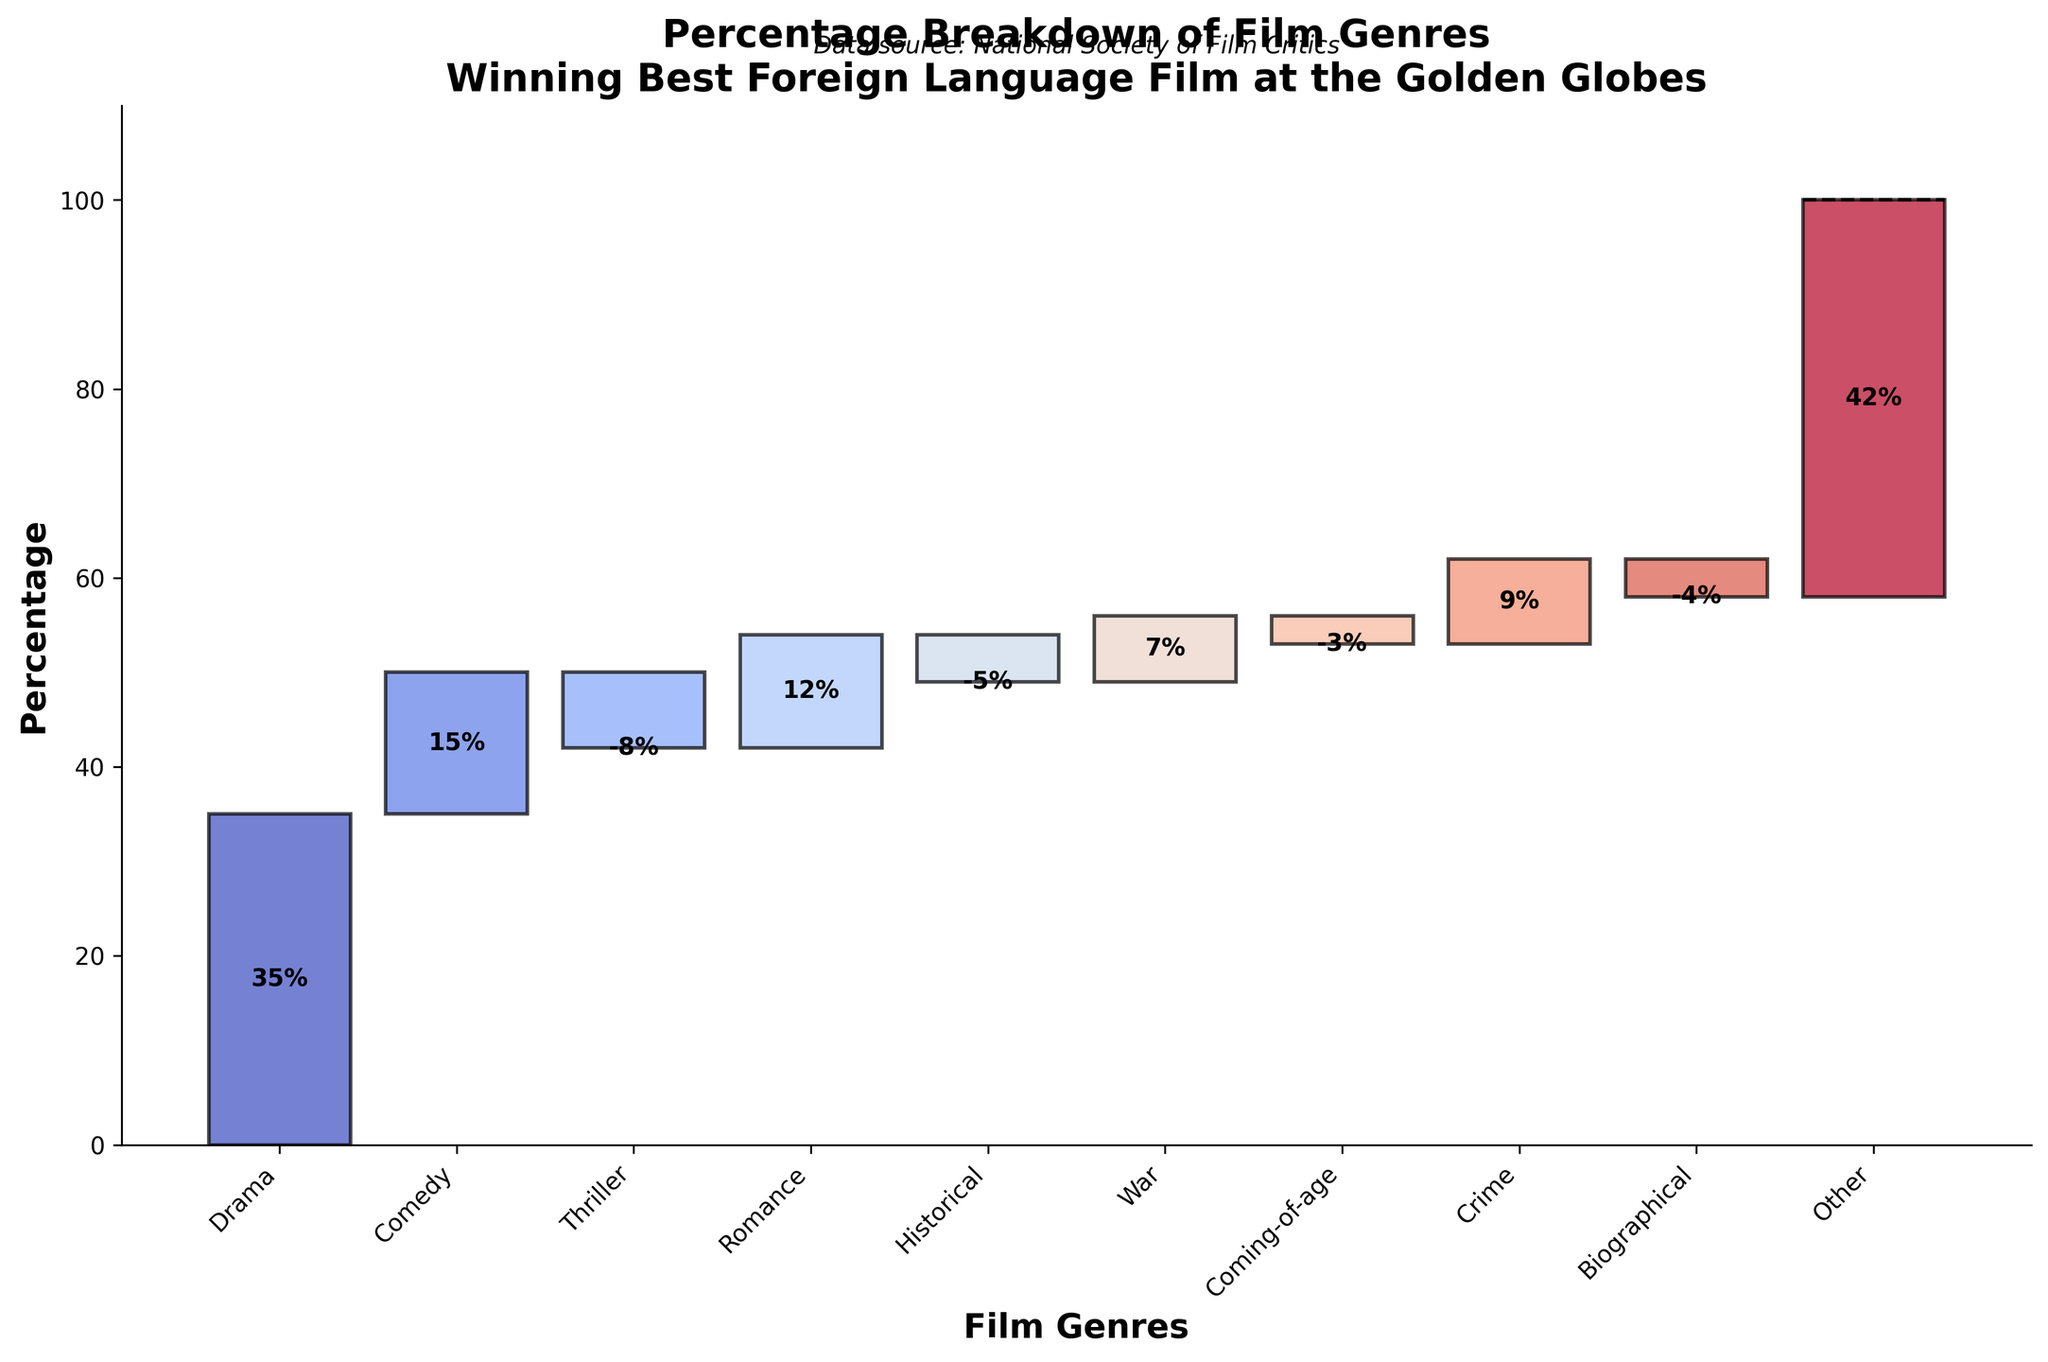What is the title of the figure? The title is usually at the top of the figure and is clearly stated.
Answer: Percentage Breakdown of Film Genres Winning Best Foreign Language Film at the Golden Globes Which genre has the highest percentage? From the figure, 'Drama' has the highest individual percentage at 35%.
Answer: Drama What is the total percentage of 'Comedy' and 'Romance' genres combined? Sum the percentages of 'Comedy' (15%) and 'Romance' (12%).
Answer: 27% Which genres have a negative percentage? The figure shows 'Thriller' (-8%), 'Historical' (-5%), 'Coming-of-age' (-3%), and 'Biographical' (-4%), as the genres with negative percentages.
Answer: Thriller, Historical, Coming-of-age, Biographical What is the net percentage total excluding the 'Other' category? Adding all genres except 'Other': 35 + 15 - 8 + 12 - 5 + 7 - 3 + 9 - 4 = 58%
Answer: 58% How does the 'Comedy' genre's percentage compare to the 'War' genre? 'Comedy' (15%) has a higher percentage than 'War' (7%)
Answer: Comedy has a higher percentage than War Which genre's percentage lies exactly in the middle of all the values? Arrange the percentages in order: -8, -5, -4, -3, 7, 9, 12, 15, 35. The median is 7 ('War' genre).
Answer: War What is the cumulative percentage after adding the 'Crime' genre? Sum the cumulative percentages up to 'Crime': 35 + 15 - 8 + 12 - 5 + 7 - 3 + 9 = 62%
Answer: 62% Describe the visual element that indicates the data source for the figure. The data source credit is usually found at the bottom or within a text box in the figure. In this case, it is "Data source: National Society of Film Critics" at the bottom.
Answer: Data source: National Society of Film Critics Which genre contributes the least to the total percentage? 'Thriller' has the least contribution with -8%.
Answer: Thriller 